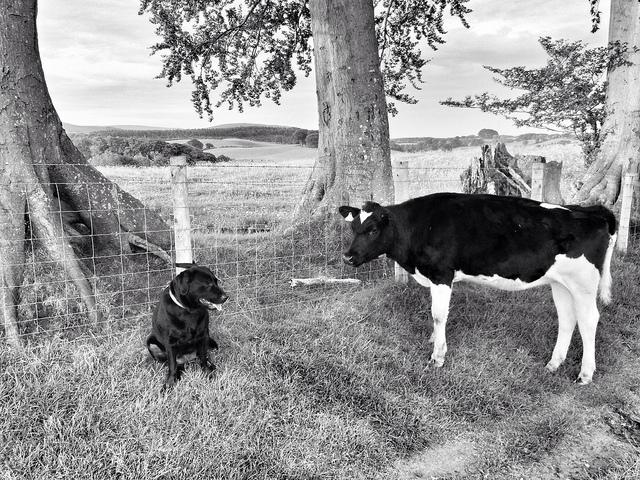What is the number of animals?
Be succinct. 2. Is the cow going to attack the dog?
Short answer required. No. How many animals are in this picture?
Be succinct. 2. 